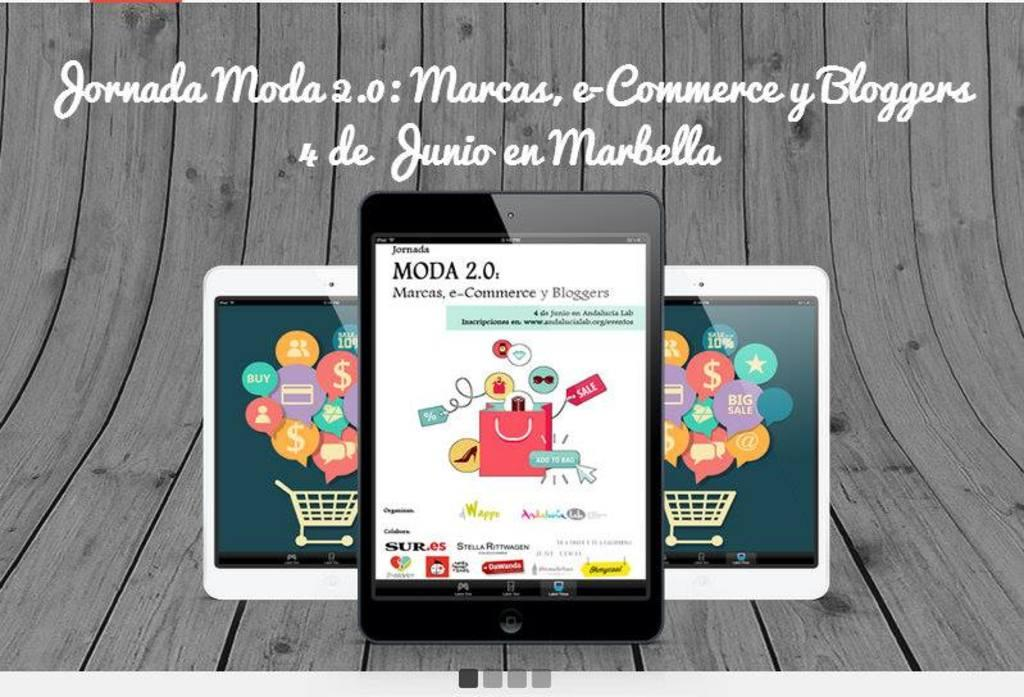<image>
Write a terse but informative summary of the picture. 3 tablets that have the app Moda 2.0 on them 